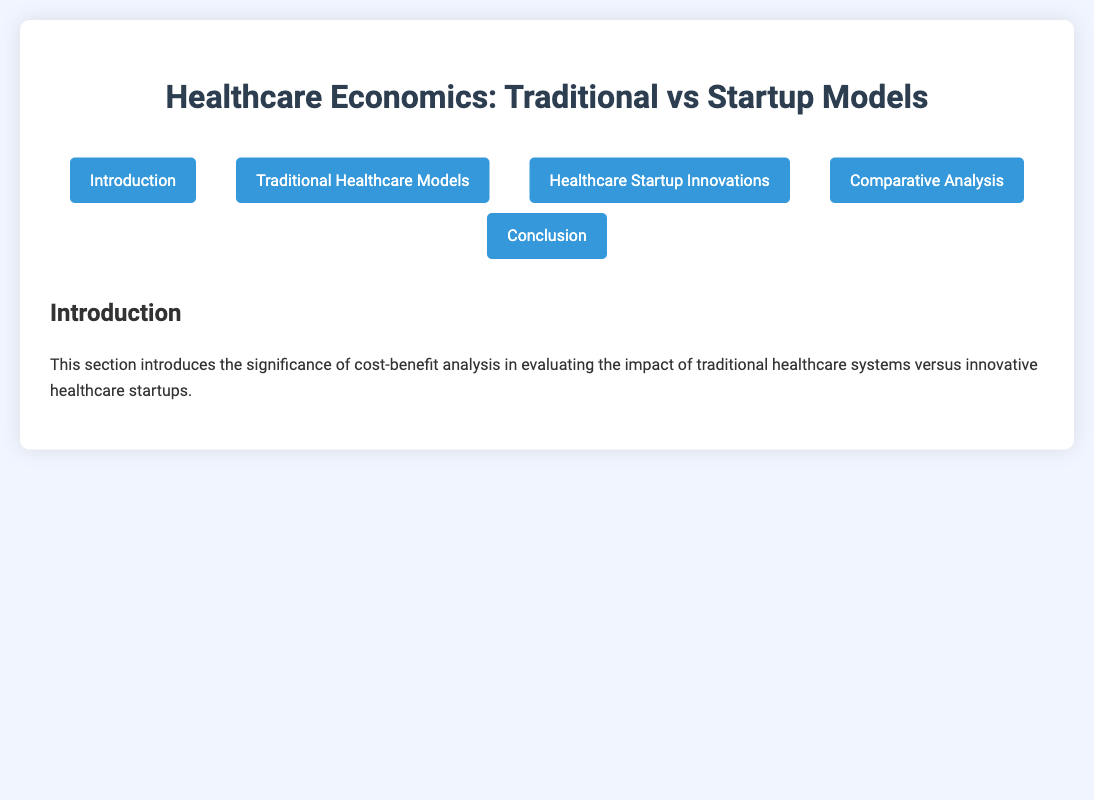What is the annual expenditure of traditional healthcare? This can be found in the comparative analysis section which lists the annual expenditure for traditional healthcare.
Answer: $450 billion What is the average patient wait time for telehealth consultations? This information is provided in the healthcare startup innovations section that discusses patient wait times for telehealth services.
Answer: 5 minutes What model type does Kaiser Permanente use? This information can be retrieved from the example entity section discussing traditional healthcare models.
Answer: Integrated managed care What is the efficiency rate of healthcare startups? This can be found in the comparative analysis summary table that lists the efficiency rates of both traditional healthcare and startups.
Answer: 85% What is the operational cost for a telehealth visit? The healthcare startup innovations section details the operational costs associated with telehealth services.
Answer: $10-$20 per telehealth visit How long is the average patient wait time in traditional healthcare? This information is included in the cost details of traditional healthcare models under patient wait time.
Answer: 24 days What healthcare innovation type is associated with Zocdoc? This information is given in the healthcare startup innovations section under the example entity for Zocdoc.
Answer: Healthcare appointment booking platform What is the total estimated annual expenditure for healthcare startups? This is mentioned in the comparative analysis section summarizing the financial aspects of healthcare startups.
Answer: $30 billion 